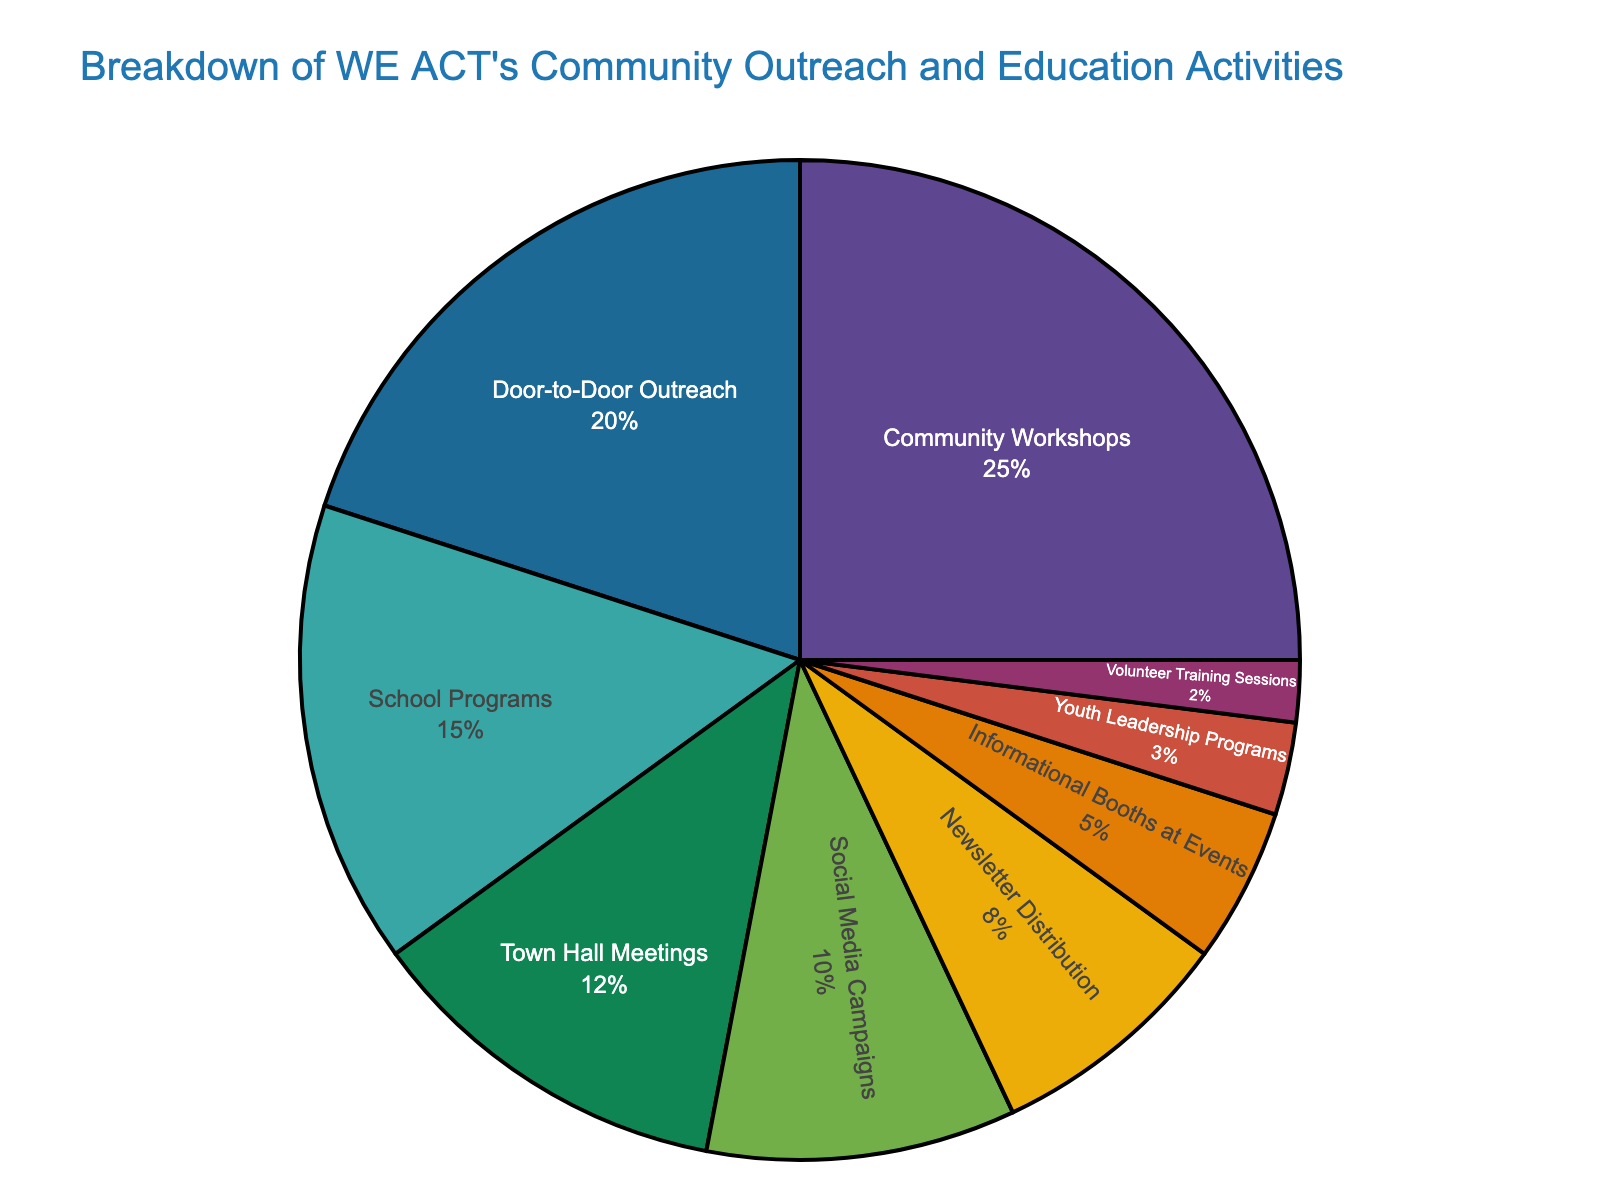Which category has the largest percentage? By observing the pie chart, the category segment with the largest slice represents the highest percentage. The "Community Workshops" segment appears to be the largest.
Answer: Community Workshops Which two categories have the smallest percentages? By looking at the smallest slices in the pie chart, we identify the segments with the smallest percentages. "Youth Leadership Programs" and "Volunteer Training Sessions" have the smallest slices.
Answer: Youth Leadership Programs and Volunteer Training Sessions What is the total percentage of Town Hall Meetings and Social Media Campaigns? Add the percentages for "Town Hall Meetings" (12%) and "Social Media Campaigns" (10%). 12% + 10% = 22%
Answer: 22% Is the percentage of Door-to-Door Outreach greater than School Programs? Compare the slices representing "Door-to-Door Outreach" and "School Programs." The "Door-to-Door Outreach" slice (20%) is larger than the "School Programs" slice (15%).
Answer: Yes What is the difference in percentage between Community Workshops and Informational Booths at Events? Subtract the percentage of "Informational Booths at Events" (5%) from that of "Community Workshops" (25%). 25% - 5% = 20%
Answer: 20% Which slices are equal or nearly equal in size? Look for slices that are visually similar in size. "Social Media Campaigns" (10%) and "Newsletter Distribution" (8%) are close in size.
Answer: Social Media Campaigns and Newsletter Distribution What is the combination of categories that together make up around 50% of the total activities? Select categories whose percentages sum close to 50%. "Community Workshops" (25%) and "Door-to-Door Outreach" (20%) combined are close to 50%. 25% + 20% = 45%. Adding "School Programs" (15%) gets us to 60%, which is a combined value actually a bit over 50%. Hence, the best combination near 50% would be "Community Workshops" and "Door-to-Door Outreach".
Answer: Community Workshops and Door-to-Door Outreach 